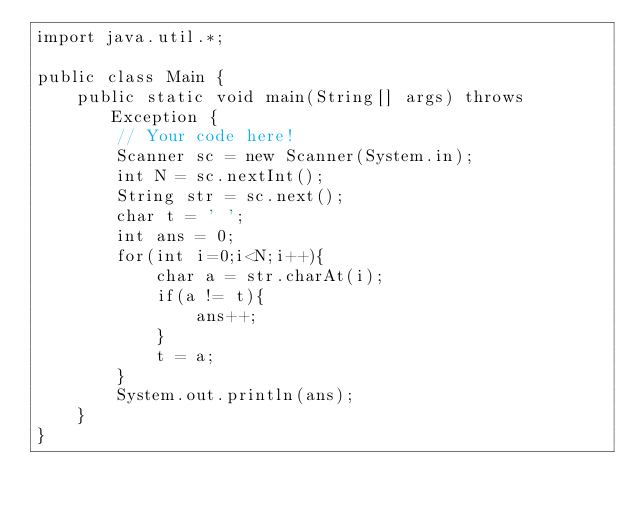Convert code to text. <code><loc_0><loc_0><loc_500><loc_500><_Java_>import java.util.*;

public class Main {
    public static void main(String[] args) throws Exception {
        // Your code here!
        Scanner sc = new Scanner(System.in);
        int N = sc.nextInt();
        String str = sc.next();
        char t = ' ';
        int ans = 0;
        for(int i=0;i<N;i++){
            char a = str.charAt(i); 
            if(a != t){
                ans++;
            }
            t = a;
        }
        System.out.println(ans);
    }
}
</code> 